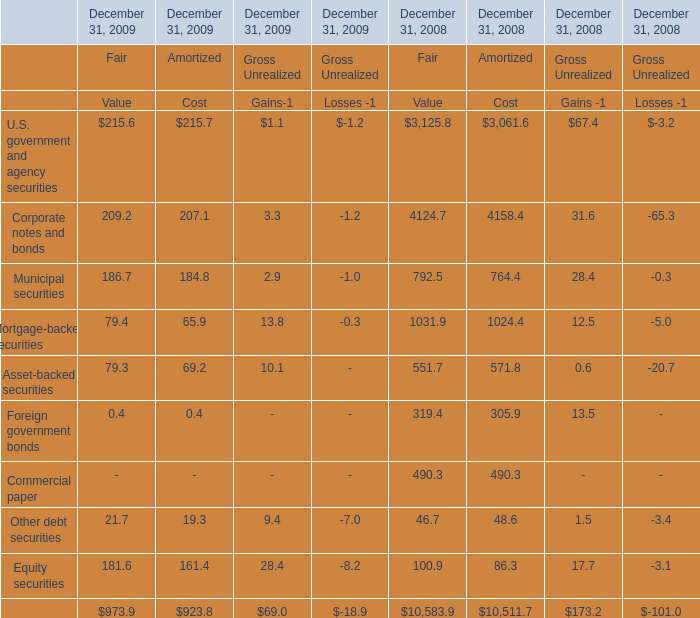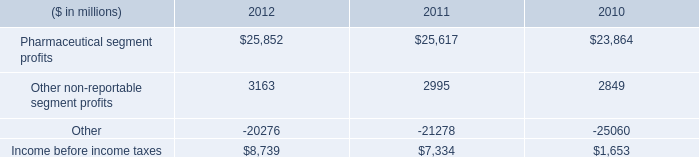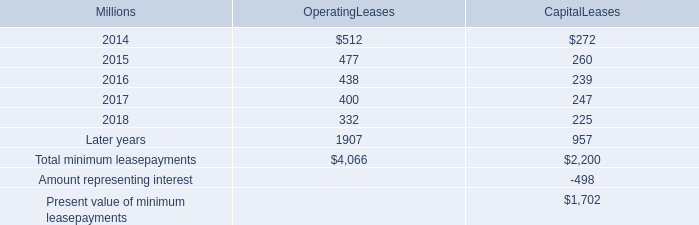as of december 31 , 2013 what was the percent of the capital lease payments related to locomotives in millions 
Computations: (2200 * 94%)
Answer: 2068.0. 